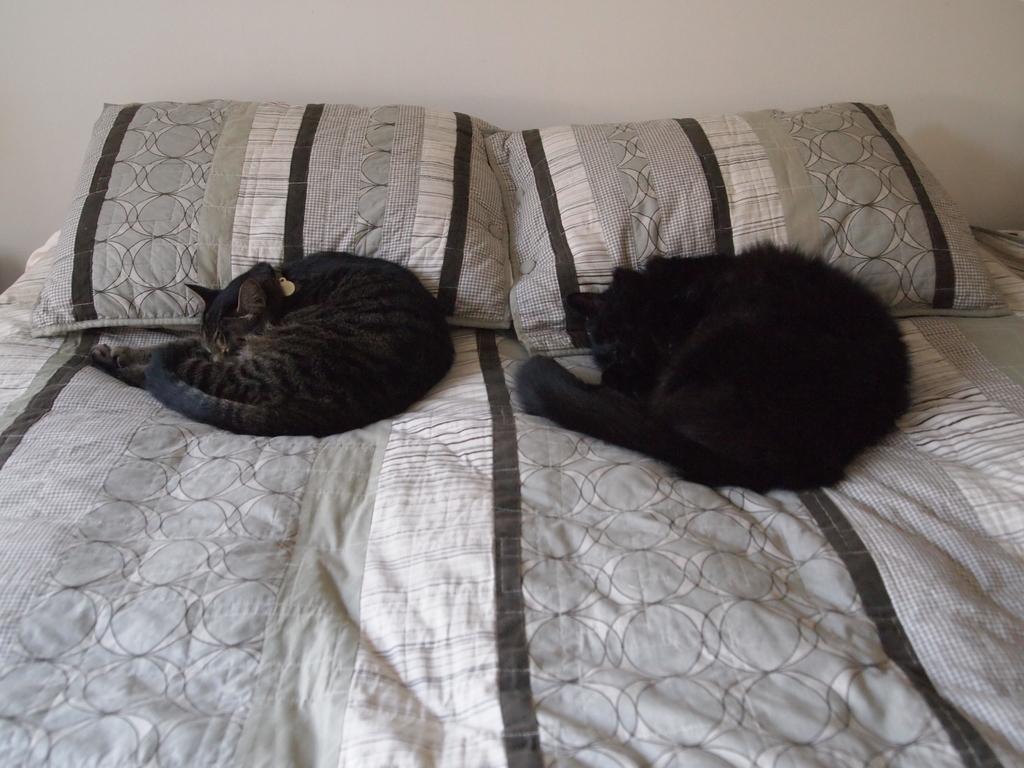Can you describe this image briefly? In this image i can see there are two cats on the bed. I can also see there are two pillows on the bed. 